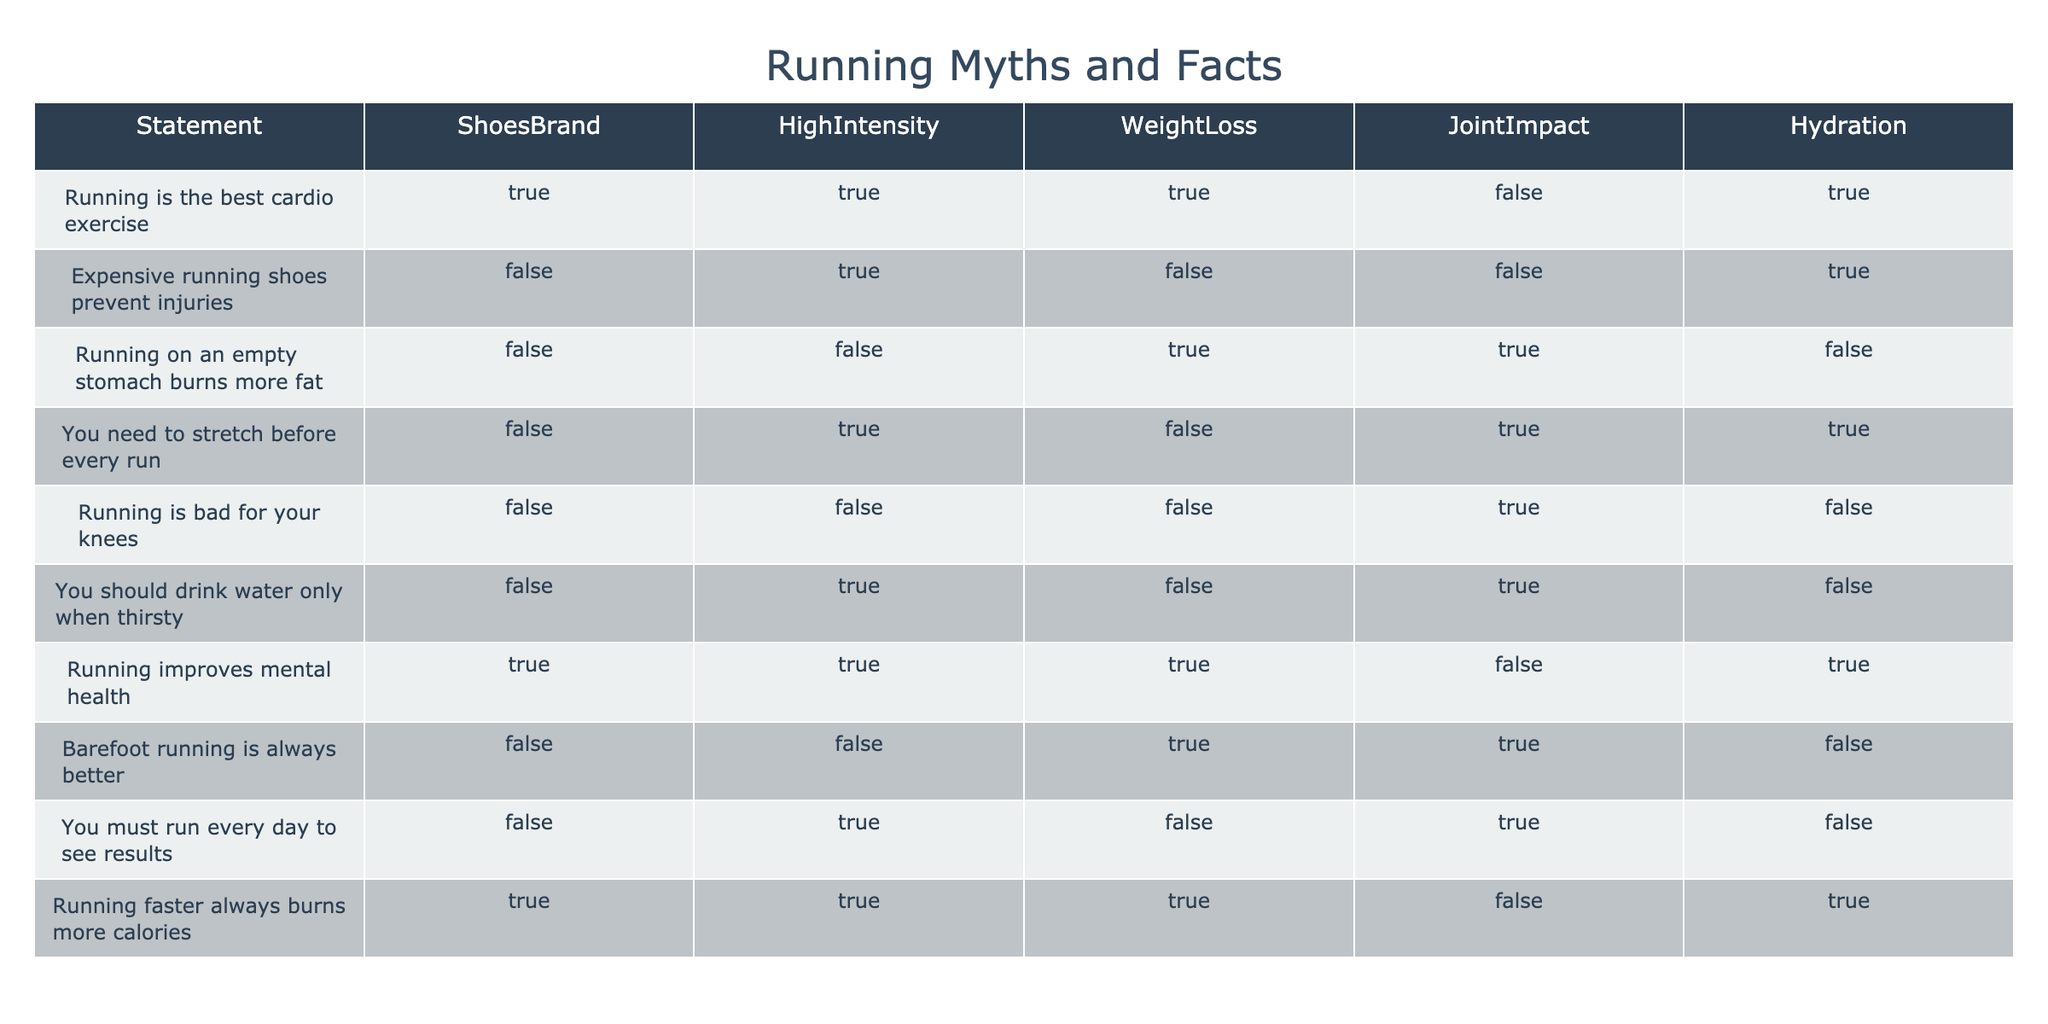What is the primary assertion of the statement "Running is the best cardio exercise"? The statement asserts that running is indeed the best form of cardio exercise, as indicated by the value TRUE in the corresponding row under the column "ShoesBrand."
Answer: TRUE Which statement claims that running on an empty stomach burns more fat? The table shows that the statement "Running on an empty stomach burns more fat" is marked FALSE under the column "WeightLoss," indicating it does not hold as a fact.
Answer: FALSE How many myths categorize running as harmful in terms of joint impact? By looking at the "JointImpact" column, we identify two statements: "Running on an empty stomach burns more fat" and "Running is bad for your knees," which are both marked TRUE. Thus, there are 2 myths regarding joint impact.
Answer: 2 Is it true that hydration should only be considered when thirsty according to the statements? The statement "You should drink water only when thirsty" has the value FALSE in the hydration column, indicating that this claim is not supported.
Answer: FALSE What percentage of the statements indicates that running improves mental health? There are 10 statements total, and 4 of them (including "Running improves mental health") indicate a positive outcome in the mental health column, thus the percentage is (4/10) * 100 = 40%.
Answer: 40% Which statements suggested that more intense running increases joint impact? We examine the "HighIntensity" column for TRUE values and find that "Running is the best cardio exercise," "Running faster always burns more calories," and "You must run every day to see results" — none of these mention increased joint impact, indicating that high-intensity running is not stated as harmful.
Answer: None Are there any statements in the table that regard hydration as unnecessary? The statement "You should drink water only when thirsty" and the assessment of "running is bad for your knees" marked TRUE in hydration implies caution but does not strictly label hydration as unnecessary.
Answer: YES What is the total number of myths asserting that expensive running shoes prevent injuries? The only statement regarding expensive running shoes preventing injury is marked FALSE, thus it does not count among the myths. Therefore, the total is 0.
Answer: 0 What logical conclusion can be drawn from the fact that "Running faster always burns more calories" is true? This statement marked TRUE in "WeightLoss" implies that running faster correlates with burning more calories, suggesting an inherent truth about the effectiveness of running in weight management.
Answer: Correlation of increased calorie burn with faster runs 